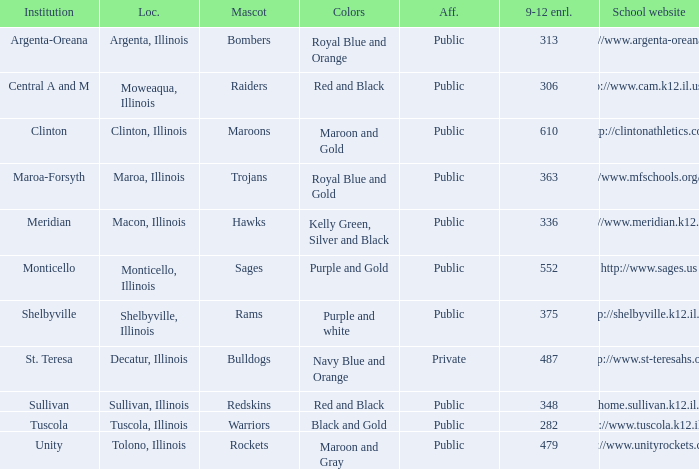What location has 363 students enrolled in the 9th to 12th grades? Maroa, Illinois. 